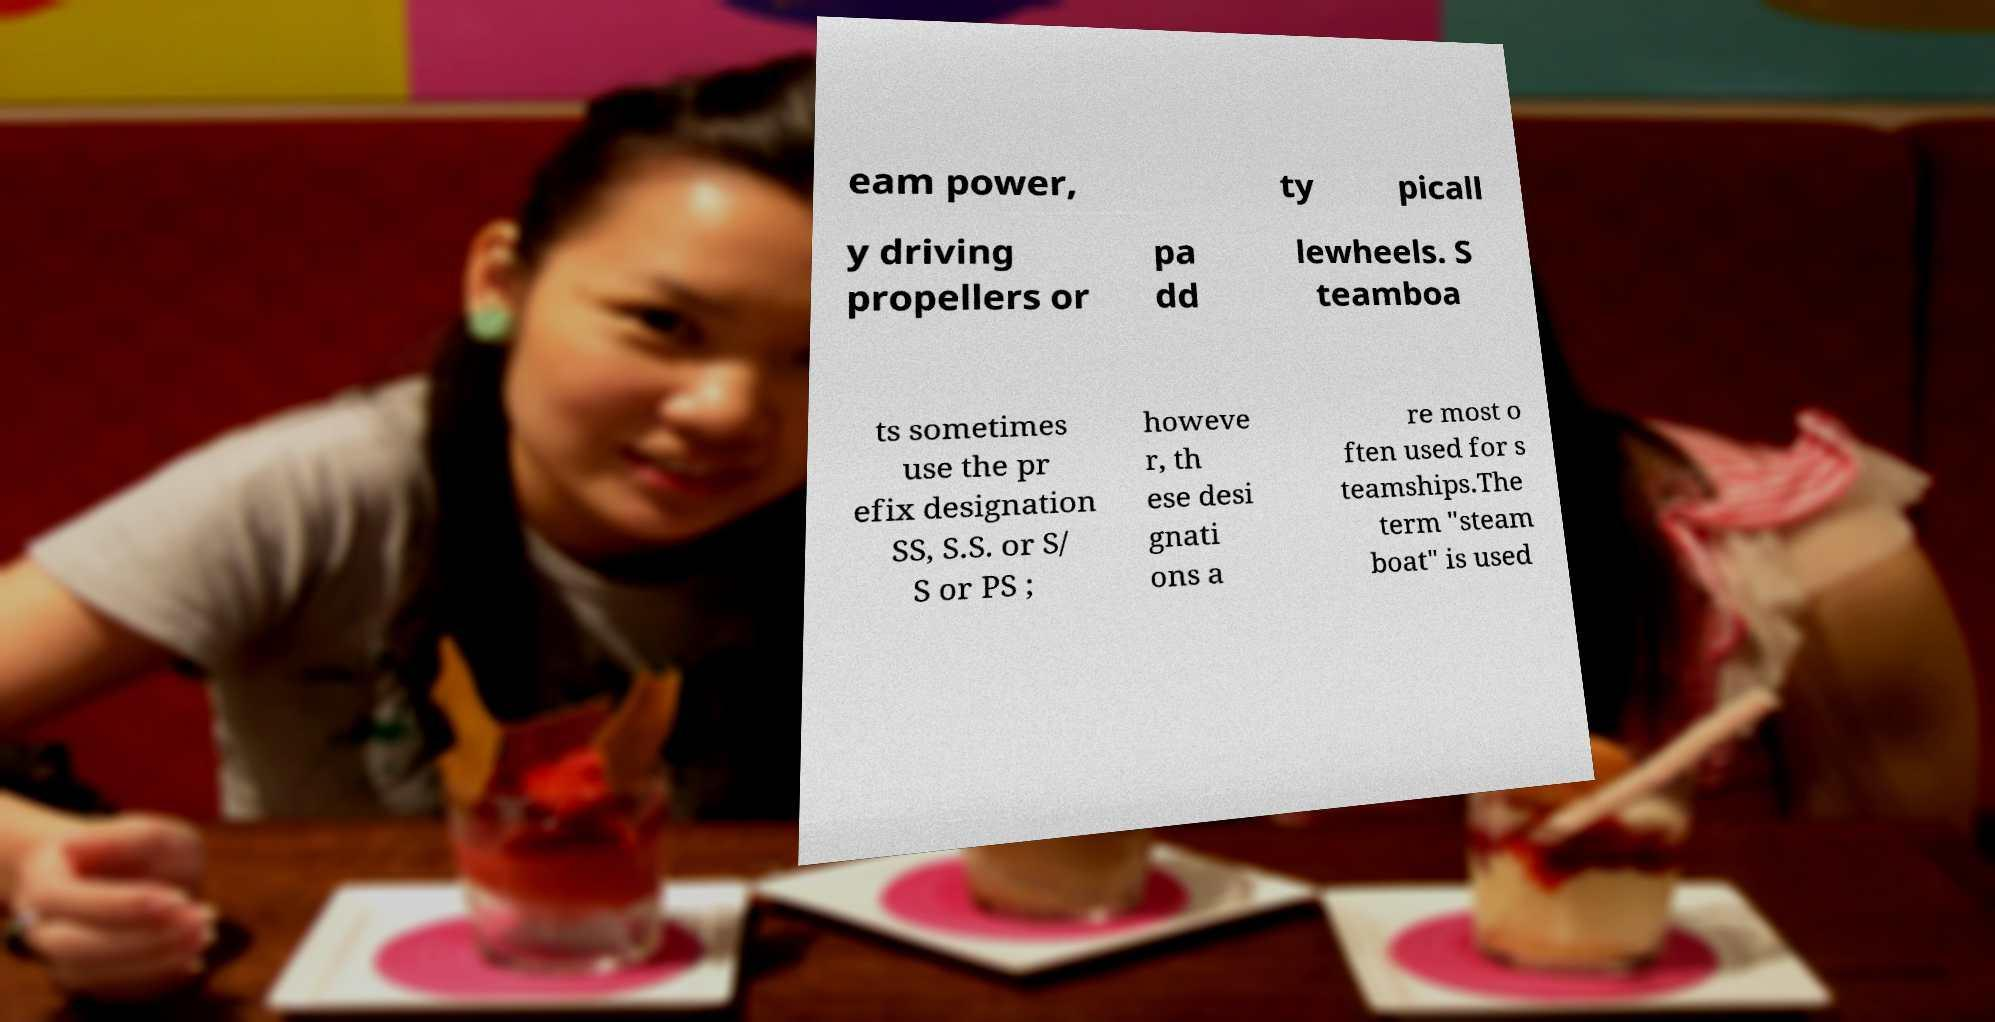Could you extract and type out the text from this image? eam power, ty picall y driving propellers or pa dd lewheels. S teamboa ts sometimes use the pr efix designation SS, S.S. or S/ S or PS ; howeve r, th ese desi gnati ons a re most o ften used for s teamships.The term "steam boat" is used 